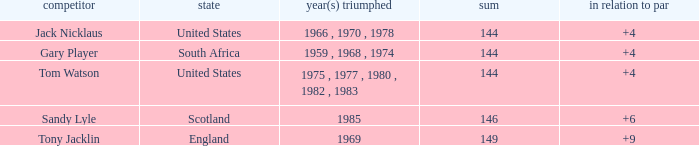What player had a To par smaller than 9 and won in 1985? Sandy Lyle. 